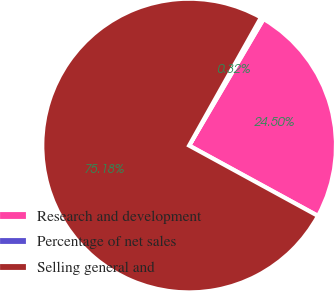<chart> <loc_0><loc_0><loc_500><loc_500><pie_chart><fcel>Research and development<fcel>Percentage of net sales<fcel>Selling general and<nl><fcel>24.5%<fcel>0.32%<fcel>75.18%<nl></chart> 